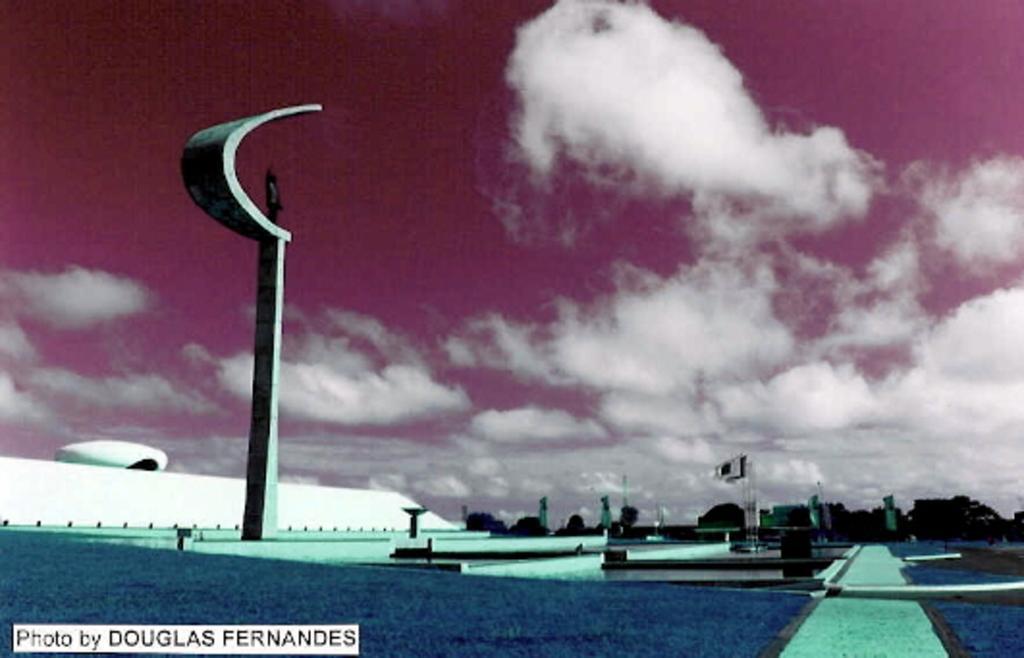Could you give a brief overview of what you see in this image? This is an animated image where there is pole, sculpture,flags, building, trees,sky and a watermark on the image. 